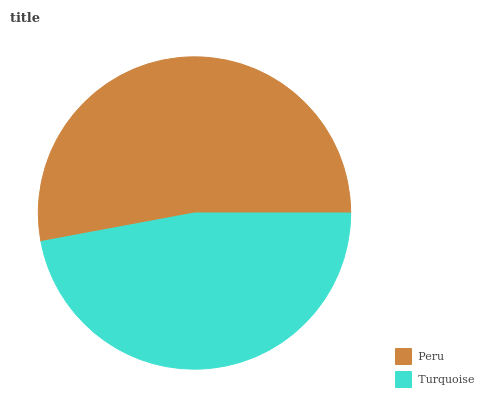Is Turquoise the minimum?
Answer yes or no. Yes. Is Peru the maximum?
Answer yes or no. Yes. Is Turquoise the maximum?
Answer yes or no. No. Is Peru greater than Turquoise?
Answer yes or no. Yes. Is Turquoise less than Peru?
Answer yes or no. Yes. Is Turquoise greater than Peru?
Answer yes or no. No. Is Peru less than Turquoise?
Answer yes or no. No. Is Peru the high median?
Answer yes or no. Yes. Is Turquoise the low median?
Answer yes or no. Yes. Is Turquoise the high median?
Answer yes or no. No. Is Peru the low median?
Answer yes or no. No. 